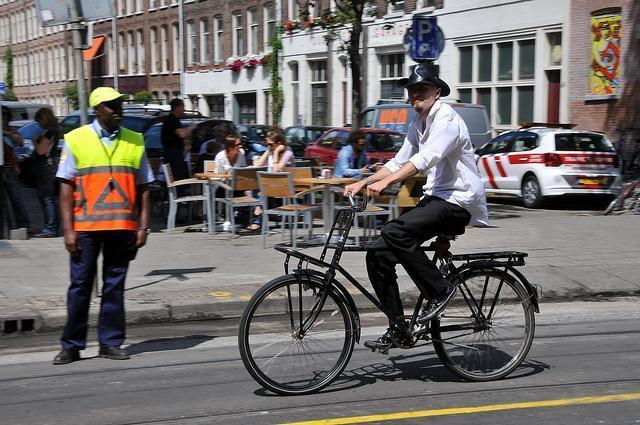How many people are on bikes?
Give a very brief answer. 1. How many bikes does the police have?
Give a very brief answer. 0. How many cars are there?
Give a very brief answer. 3. How many people are visible?
Give a very brief answer. 3. How many boats are in the water?
Give a very brief answer. 0. 